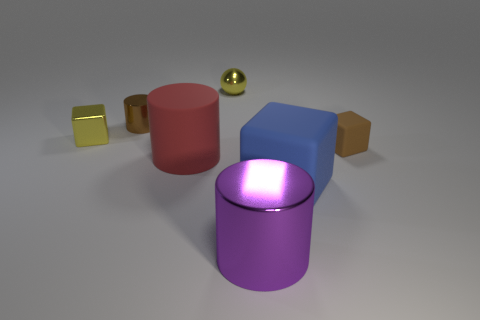Add 3 red matte things. How many objects exist? 10 Subtract all cylinders. How many objects are left? 4 Subtract 1 brown cylinders. How many objects are left? 6 Subtract all blue matte balls. Subtract all tiny brown metallic cylinders. How many objects are left? 6 Add 4 purple shiny cylinders. How many purple shiny cylinders are left? 5 Add 3 big green spheres. How many big green spheres exist? 3 